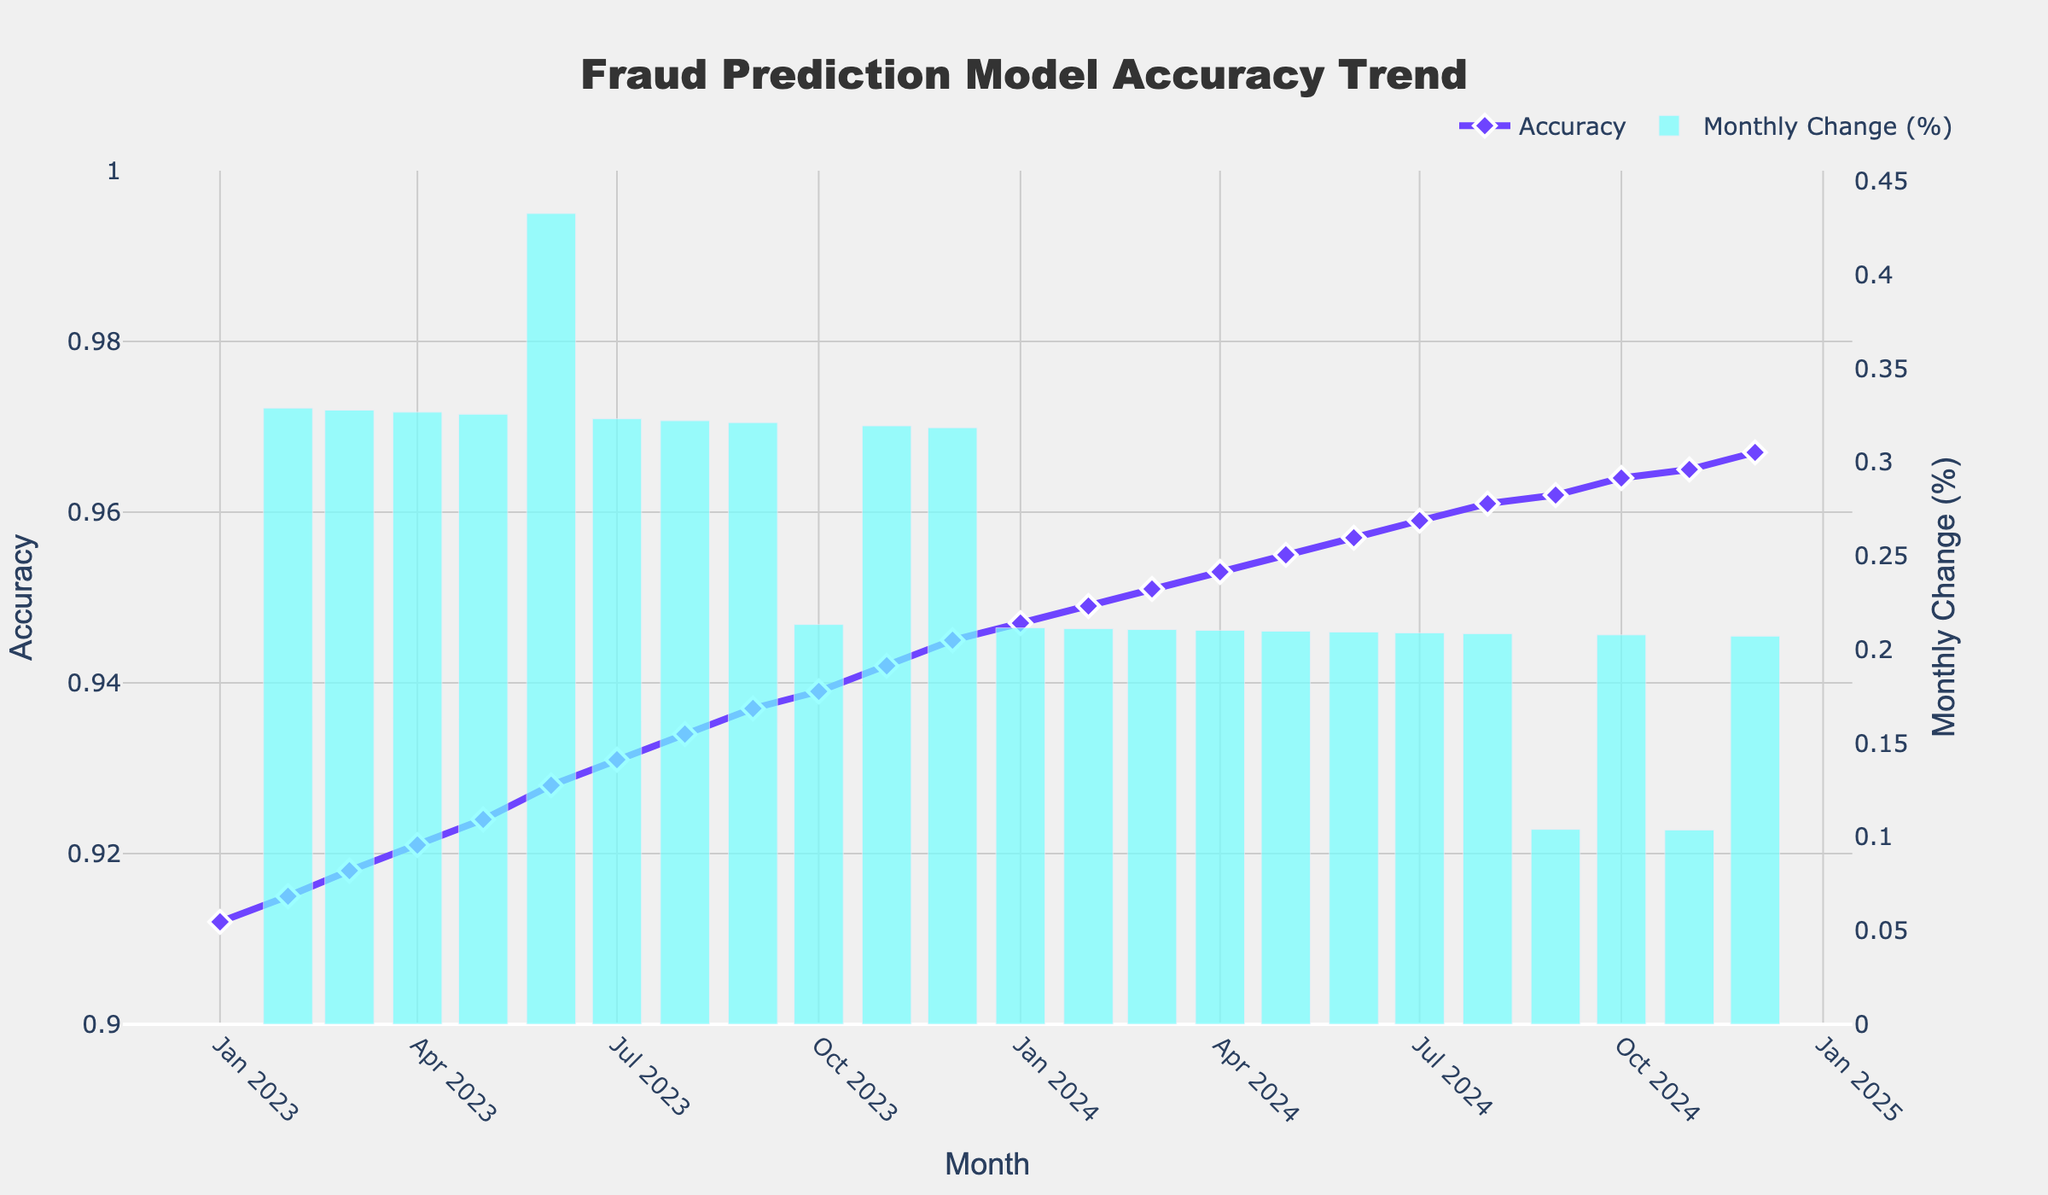What is the overall trend in the accuracy of the fraud prediction model from January 2023 to December 2024? The line on the plot representing accuracy generally increases from January 2023 to December 2024, indicating an upward trend.
Answer: Increasing What month saw the largest monthly percentage change in accuracy? The highest bar on the secondary y-axis, which represents monthly change percentage, appears in December 2023.
Answer: December 2023 What is the accuracy of the fraud prediction model in July 2023? Locate July 2023 on the x-axis, then trace the corresponding accuracy value on the primary y-axis. The value at this point is 0.931.
Answer: 0.931 How much did the accuracy improve between January 2023 and December 2024? The accuracy in January 2023 is 0.912 and in December 2024 is 0.967. The difference is 0.967 - 0.912 = 0.055.
Answer: 0.055 Looking at the two-year trend, did any month experience a decrease in the model's accuracy? Observing the line on the plot, it consistently trends upward without any drops, indicating no decreases in any month.
Answer: No Which month has the lowest accuracy, and what is its value? The month with the lowest point on the line plot is January 2023, with an accuracy value of 0.912.
Answer: January 2023, 0.912 Which month has the highest monthly percentage change, and what is its value? By examining the height of the bars on the secondary y-axis, December 2023 stands out. The percentage change can be read from this bar.
Answer: December 2023, 0.245% By how much did the accuracy improve from June 2023 to June 2024? Accuracy in June 2023 is 0.928 and in June 2024 is 0.957. The difference is 0.957 - 0.928 = 0.029.
Answer: 0.029 Is the model accuracy change percentage generally increasing, decreasing, or showing no clear trend over the two-year period? The height of the bars fluctuates over time but does not show a consistent increasing or decreasing pattern, indicating no clear trend.
Answer: No clear trend When comparing the first half of 2023 to the first half of 2024, which period saw higher average accuracy? Compute the average accuracy for Jan 2023 to Jun 2023 and Jan 2024 to Jun 2024 and compare. The averages are (0.912 + 0.915 + 0.918 + 0.921 + 0.924 + 0.928)/6 for 2023 = 0.9197, and (0.947 + 0.949 + 0.951 + 0.953 + 0.955 + 0.957)/6 for 2024 = 0.952.
Answer: First half of 2024 